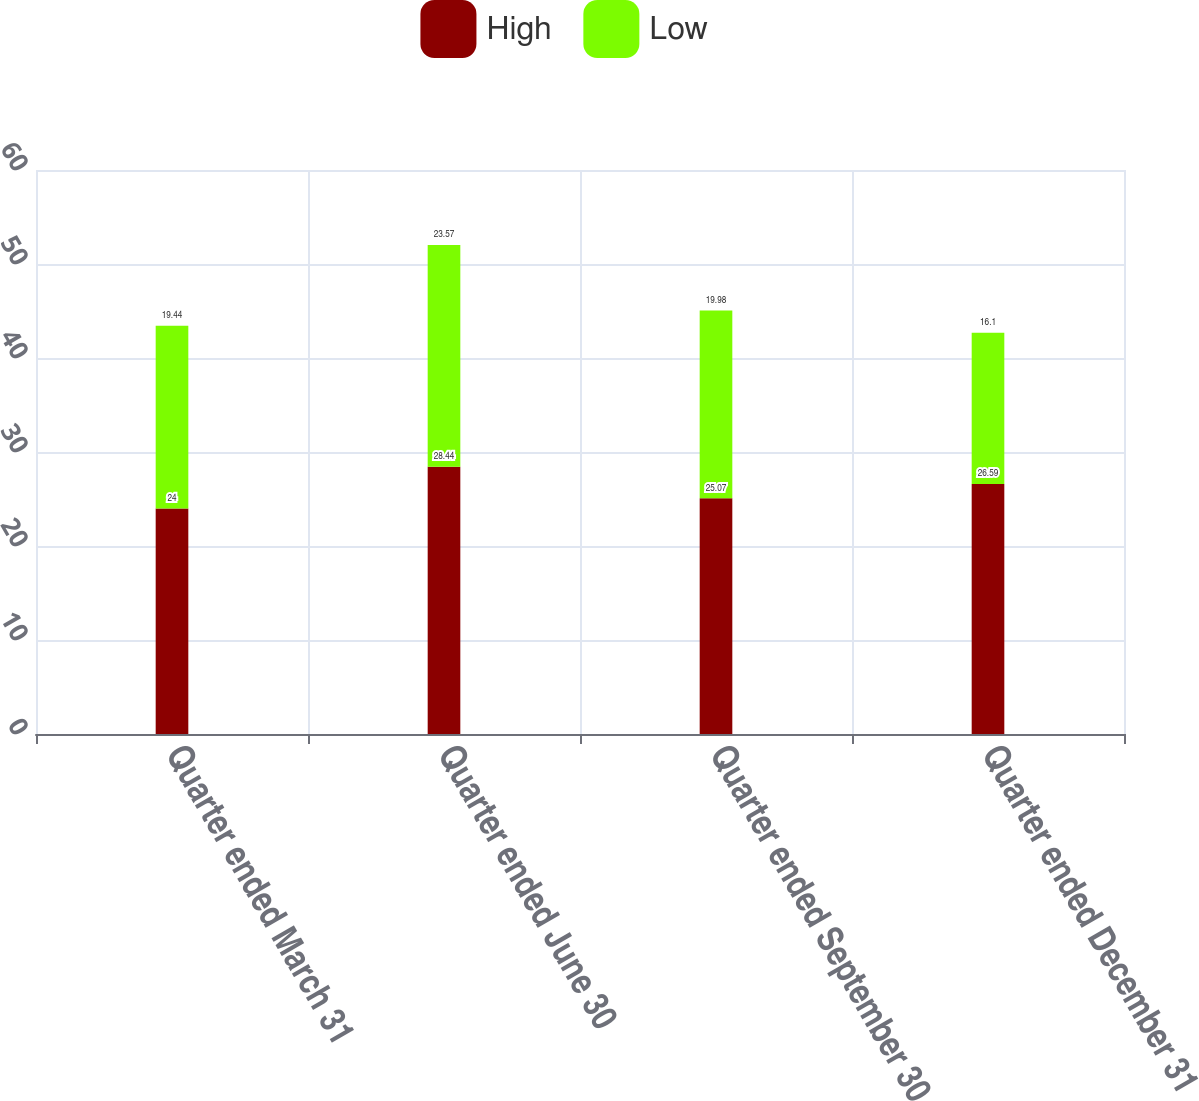Convert chart. <chart><loc_0><loc_0><loc_500><loc_500><stacked_bar_chart><ecel><fcel>Quarter ended March 31<fcel>Quarter ended June 30<fcel>Quarter ended September 30<fcel>Quarter ended December 31<nl><fcel>High<fcel>24<fcel>28.44<fcel>25.07<fcel>26.59<nl><fcel>Low<fcel>19.44<fcel>23.57<fcel>19.98<fcel>16.1<nl></chart> 